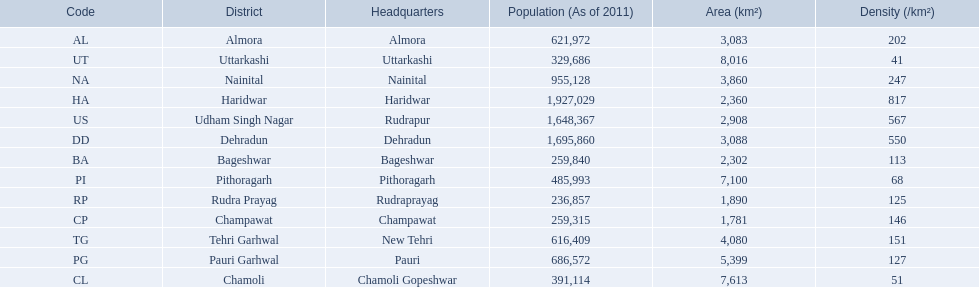What are the names of all the districts? Almora, Bageshwar, Chamoli, Champawat, Dehradun, Haridwar, Nainital, Pauri Garhwal, Pithoragarh, Rudra Prayag, Tehri Garhwal, Udham Singh Nagar, Uttarkashi. What range of densities do these districts encompass? 202, 113, 51, 146, 550, 817, 247, 127, 68, 125, 151, 567, 41. Which district has a density of 51? Chamoli. 